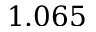Convert formula to latex. <formula><loc_0><loc_0><loc_500><loc_500>1 . 0 6 5</formula> 